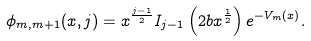<formula> <loc_0><loc_0><loc_500><loc_500>\phi _ { m , m + 1 } ( x , j ) = x ^ { \frac { j - 1 } { 2 } } I _ { j - 1 } \left ( 2 b x ^ { \frac { 1 } { 2 } } \right ) e ^ { - V _ { m } ( x ) } .</formula> 